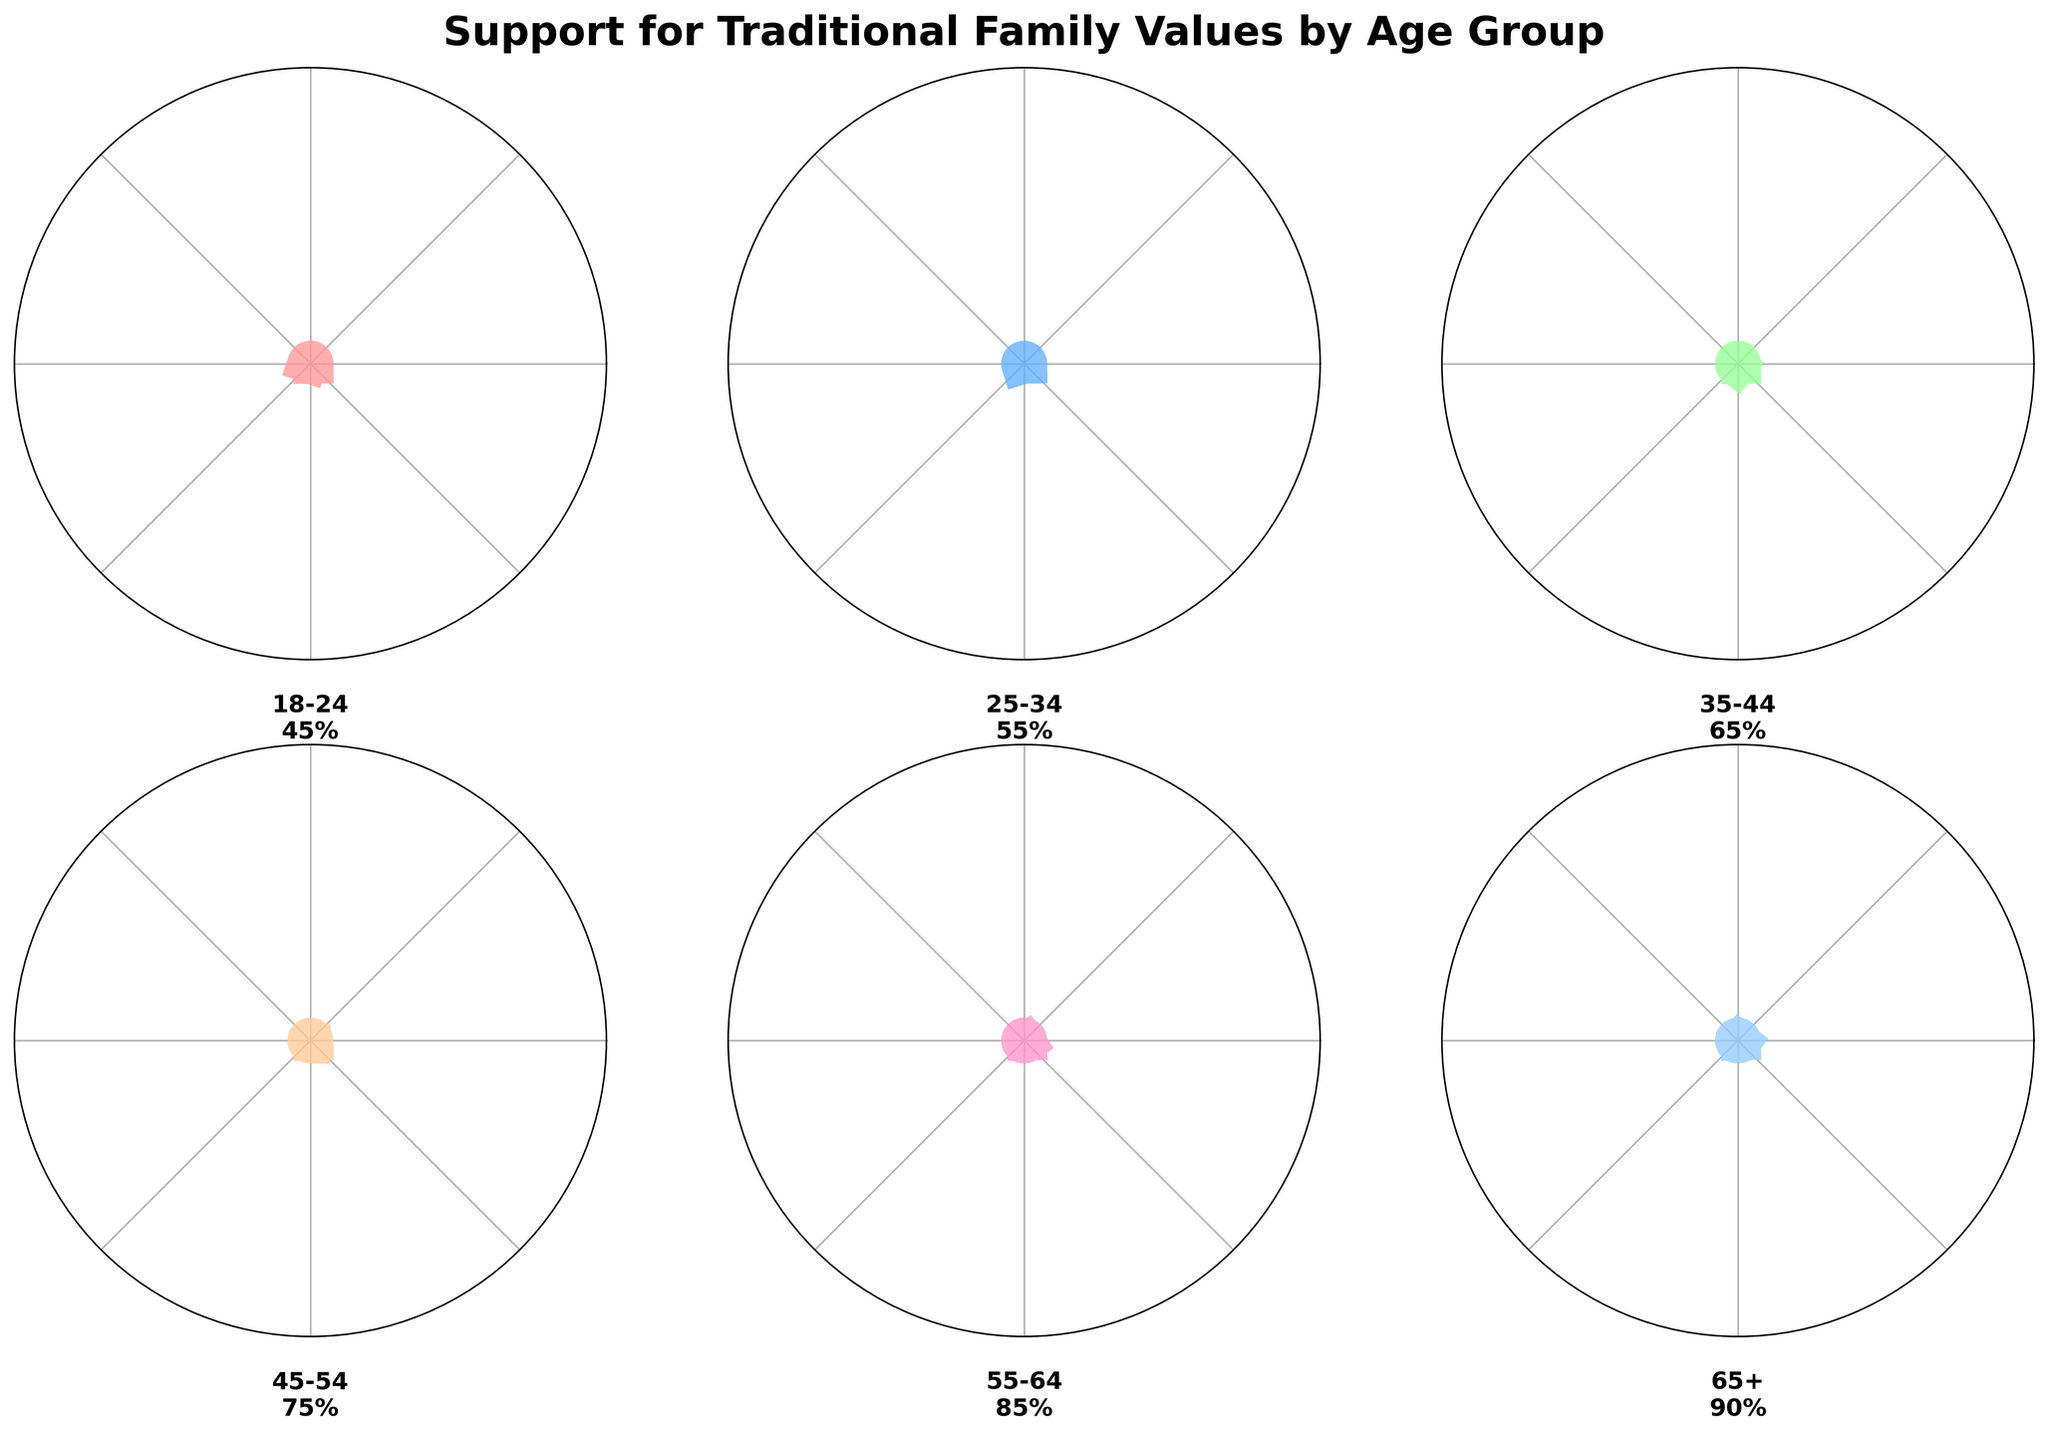Which age group has the highest level of support for traditional family values? The figure shows different age groups with various support levels. The age group with the highest value will be the one with the highest percentage on the gauge. In this figure, the 65+ age group has the highest level of support at 90%.
Answer: 65+ What is the difference in support levels between the 25-34 age group and the 18-24 age group? The support level for the 25-34 age group is 55%, and for the 18-24 age group, it is 45%. The difference can be calculated as 55% - 45% which equals 10%.
Answer: 10% Which age groups have a support level of 75% or higher? The age groups clearly displayed in the figure with support levels at 75% or higher are the ones at 75%, 85%, and 90%. These correspond to the 45-54, 55-64, and 65+ age groups.
Answer: 45-54, 55-64, 65+ What is the average level of support for traditional family values across all age groups? To calculate the average support level, sum all the percentage values for each age group and divide by the number of age groups. The sum is 45 + 55 + 65 + 75 + 85 + 90 = 415. There are 6 age groups, so the average is 415 / 6 ≈ 69.17%.
Answer: 69.17% Between which two consecutive age groups is the increase in support level the highest? Inspecting the figure's percentage differences between each consecutive age group: 55-45 = 10 (18-24 to 25-34), 65-55 = 10 (25-34 to 35-44), 75-65 = 10 (35-44 to 45-54), 85-75 = 10 (45-54 to 55-64), 90-85 = 5 (55-64 to 65+). All changes except for the last show an increase of 10%. Hence, multiple pairs (18-24 to 25-34, 25-34 to 35-44, 35-44 to 45-54, 45-54 to 55-64) show the highest increase.
Answer: 18-24 to 25-34, 25-34 to 35-44, 35-44 to 45-54, 45-54 to 55-64 How much greater is the support level of the 35-44 age group compared to the 18-24 age group? The support level for the 35-44 age group is 65%, and for the 18-24 age group, it is 45%. The difference can be calculated as 65% - 45% which equals 20%.
Answer: 20% Which age group's support level is closest to the average level of support across all age groups? The average level of support across all age groups is approximately 69.17%. The closest support levels are 65% (35-44 age group) and 75% (45-54 age group). Both are equally close at a difference of approximately 4.17%.
Answer: 35-44, 45-54 